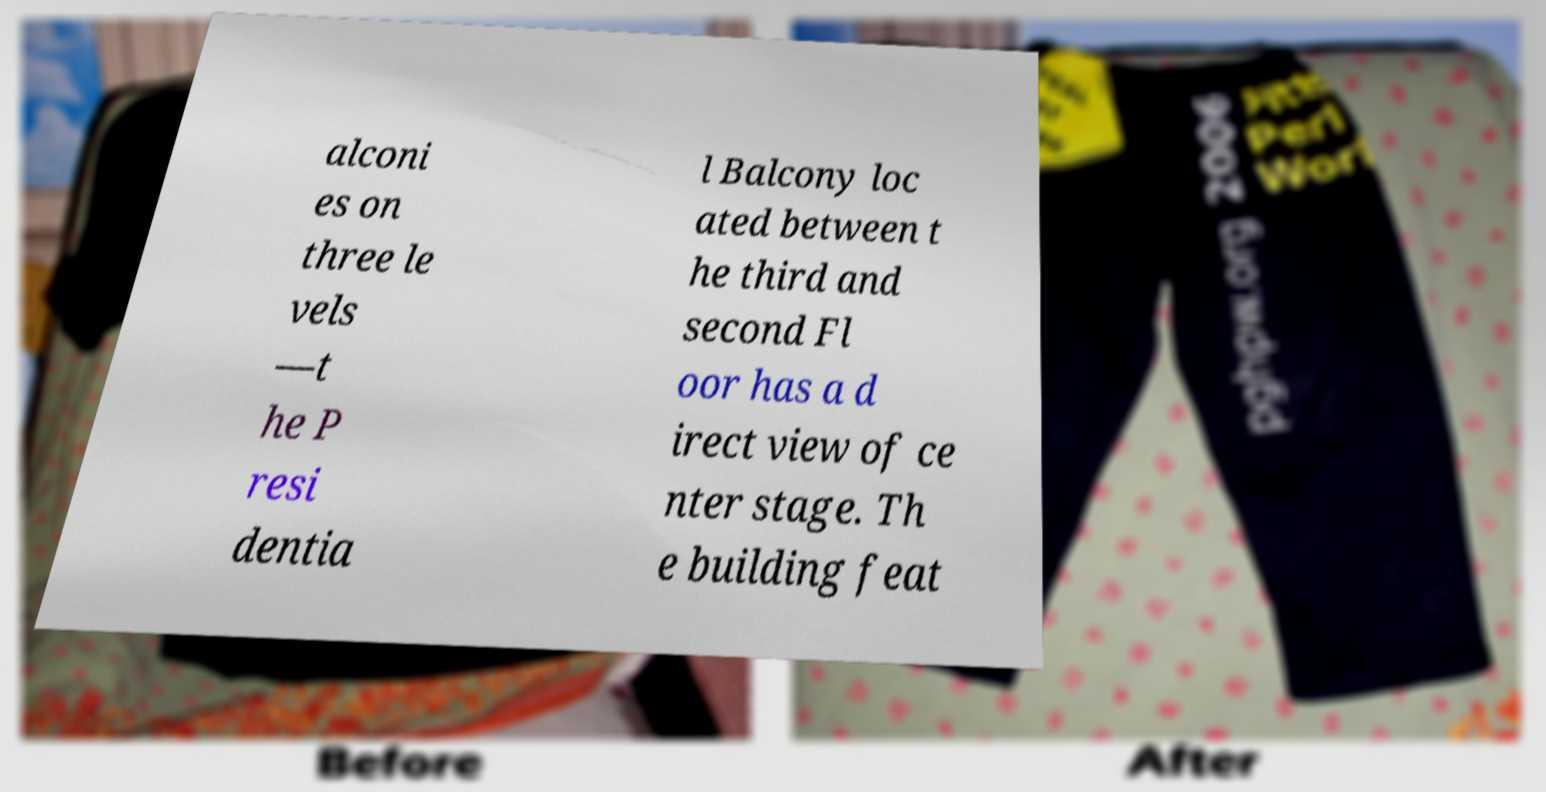Please identify and transcribe the text found in this image. alconi es on three le vels —t he P resi dentia l Balcony loc ated between t he third and second Fl oor has a d irect view of ce nter stage. Th e building feat 